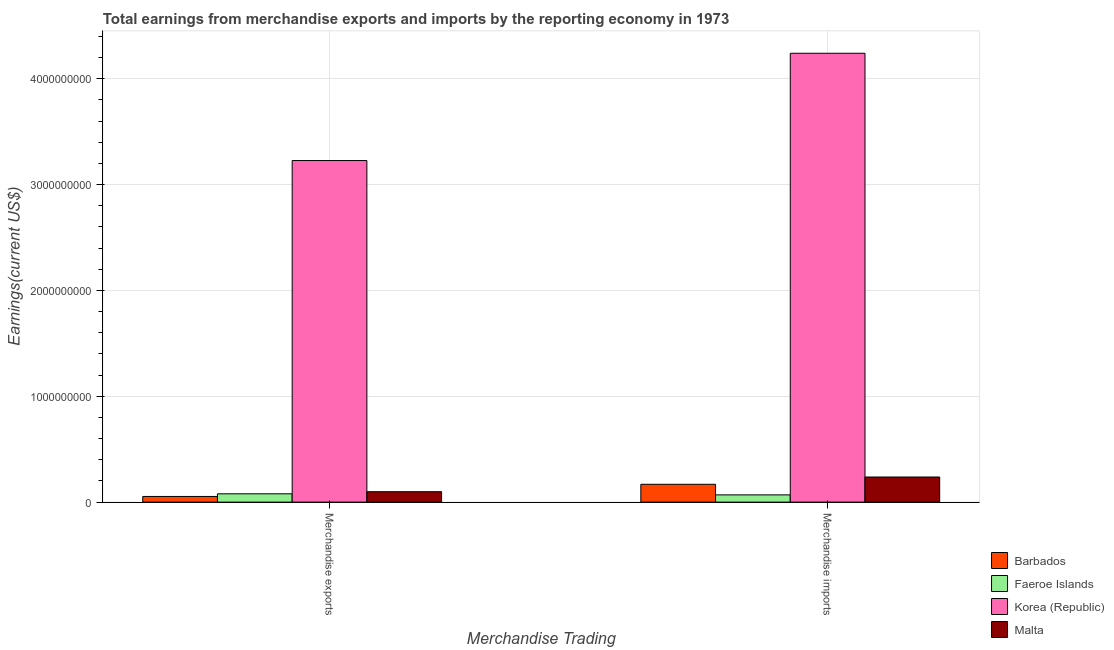How many different coloured bars are there?
Provide a succinct answer. 4. Are the number of bars per tick equal to the number of legend labels?
Ensure brevity in your answer.  Yes. Are the number of bars on each tick of the X-axis equal?
Your answer should be very brief. Yes. How many bars are there on the 1st tick from the left?
Your response must be concise. 4. What is the earnings from merchandise exports in Barbados?
Ensure brevity in your answer.  5.35e+07. Across all countries, what is the maximum earnings from merchandise imports?
Provide a succinct answer. 4.24e+09. Across all countries, what is the minimum earnings from merchandise exports?
Your answer should be compact. 5.35e+07. In which country was the earnings from merchandise exports maximum?
Provide a short and direct response. Korea (Republic). In which country was the earnings from merchandise imports minimum?
Give a very brief answer. Faeroe Islands. What is the total earnings from merchandise imports in the graph?
Give a very brief answer. 4.72e+09. What is the difference between the earnings from merchandise exports in Faeroe Islands and that in Korea (Republic)?
Give a very brief answer. -3.15e+09. What is the difference between the earnings from merchandise imports in Korea (Republic) and the earnings from merchandise exports in Malta?
Provide a succinct answer. 4.14e+09. What is the average earnings from merchandise imports per country?
Your answer should be compact. 1.18e+09. What is the difference between the earnings from merchandise imports and earnings from merchandise exports in Faeroe Islands?
Keep it short and to the point. -1.01e+07. In how many countries, is the earnings from merchandise imports greater than 600000000 US$?
Provide a short and direct response. 1. What is the ratio of the earnings from merchandise exports in Barbados to that in Malta?
Ensure brevity in your answer.  0.54. What does the 1st bar from the left in Merchandise imports represents?
Offer a very short reply. Barbados. What does the 3rd bar from the right in Merchandise imports represents?
Your answer should be compact. Faeroe Islands. How many bars are there?
Give a very brief answer. 8. Are all the bars in the graph horizontal?
Offer a very short reply. No. How many countries are there in the graph?
Your answer should be very brief. 4. What is the difference between two consecutive major ticks on the Y-axis?
Make the answer very short. 1.00e+09. Does the graph contain any zero values?
Give a very brief answer. No. How many legend labels are there?
Give a very brief answer. 4. How are the legend labels stacked?
Keep it short and to the point. Vertical. What is the title of the graph?
Your answer should be very brief. Total earnings from merchandise exports and imports by the reporting economy in 1973. What is the label or title of the X-axis?
Your response must be concise. Merchandise Trading. What is the label or title of the Y-axis?
Ensure brevity in your answer.  Earnings(current US$). What is the Earnings(current US$) of Barbados in Merchandise exports?
Your answer should be very brief. 5.35e+07. What is the Earnings(current US$) of Faeroe Islands in Merchandise exports?
Give a very brief answer. 7.85e+07. What is the Earnings(current US$) of Korea (Republic) in Merchandise exports?
Give a very brief answer. 3.23e+09. What is the Earnings(current US$) in Malta in Merchandise exports?
Provide a succinct answer. 9.85e+07. What is the Earnings(current US$) of Barbados in Merchandise imports?
Your answer should be very brief. 1.69e+08. What is the Earnings(current US$) of Faeroe Islands in Merchandise imports?
Your answer should be compact. 6.85e+07. What is the Earnings(current US$) of Korea (Republic) in Merchandise imports?
Provide a short and direct response. 4.24e+09. What is the Earnings(current US$) of Malta in Merchandise imports?
Offer a very short reply. 2.37e+08. Across all Merchandise Trading, what is the maximum Earnings(current US$) of Barbados?
Offer a terse response. 1.69e+08. Across all Merchandise Trading, what is the maximum Earnings(current US$) of Faeroe Islands?
Make the answer very short. 7.85e+07. Across all Merchandise Trading, what is the maximum Earnings(current US$) of Korea (Republic)?
Ensure brevity in your answer.  4.24e+09. Across all Merchandise Trading, what is the maximum Earnings(current US$) of Malta?
Your answer should be compact. 2.37e+08. Across all Merchandise Trading, what is the minimum Earnings(current US$) of Barbados?
Give a very brief answer. 5.35e+07. Across all Merchandise Trading, what is the minimum Earnings(current US$) in Faeroe Islands?
Offer a very short reply. 6.85e+07. Across all Merchandise Trading, what is the minimum Earnings(current US$) of Korea (Republic)?
Ensure brevity in your answer.  3.23e+09. Across all Merchandise Trading, what is the minimum Earnings(current US$) of Malta?
Make the answer very short. 9.85e+07. What is the total Earnings(current US$) in Barbados in the graph?
Make the answer very short. 2.22e+08. What is the total Earnings(current US$) of Faeroe Islands in the graph?
Your answer should be compact. 1.47e+08. What is the total Earnings(current US$) of Korea (Republic) in the graph?
Your answer should be very brief. 7.47e+09. What is the total Earnings(current US$) in Malta in the graph?
Give a very brief answer. 3.36e+08. What is the difference between the Earnings(current US$) in Barbados in Merchandise exports and that in Merchandise imports?
Keep it short and to the point. -1.15e+08. What is the difference between the Earnings(current US$) in Faeroe Islands in Merchandise exports and that in Merchandise imports?
Your answer should be compact. 1.01e+07. What is the difference between the Earnings(current US$) in Korea (Republic) in Merchandise exports and that in Merchandise imports?
Ensure brevity in your answer.  -1.01e+09. What is the difference between the Earnings(current US$) of Malta in Merchandise exports and that in Merchandise imports?
Your answer should be very brief. -1.39e+08. What is the difference between the Earnings(current US$) in Barbados in Merchandise exports and the Earnings(current US$) in Faeroe Islands in Merchandise imports?
Provide a succinct answer. -1.49e+07. What is the difference between the Earnings(current US$) of Barbados in Merchandise exports and the Earnings(current US$) of Korea (Republic) in Merchandise imports?
Offer a terse response. -4.19e+09. What is the difference between the Earnings(current US$) in Barbados in Merchandise exports and the Earnings(current US$) in Malta in Merchandise imports?
Keep it short and to the point. -1.84e+08. What is the difference between the Earnings(current US$) of Faeroe Islands in Merchandise exports and the Earnings(current US$) of Korea (Republic) in Merchandise imports?
Your response must be concise. -4.16e+09. What is the difference between the Earnings(current US$) of Faeroe Islands in Merchandise exports and the Earnings(current US$) of Malta in Merchandise imports?
Make the answer very short. -1.59e+08. What is the difference between the Earnings(current US$) of Korea (Republic) in Merchandise exports and the Earnings(current US$) of Malta in Merchandise imports?
Provide a short and direct response. 2.99e+09. What is the average Earnings(current US$) in Barbados per Merchandise Trading?
Your answer should be compact. 1.11e+08. What is the average Earnings(current US$) of Faeroe Islands per Merchandise Trading?
Your answer should be very brief. 7.35e+07. What is the average Earnings(current US$) of Korea (Republic) per Merchandise Trading?
Make the answer very short. 3.73e+09. What is the average Earnings(current US$) in Malta per Merchandise Trading?
Keep it short and to the point. 1.68e+08. What is the difference between the Earnings(current US$) in Barbados and Earnings(current US$) in Faeroe Islands in Merchandise exports?
Make the answer very short. -2.50e+07. What is the difference between the Earnings(current US$) in Barbados and Earnings(current US$) in Korea (Republic) in Merchandise exports?
Your answer should be very brief. -3.17e+09. What is the difference between the Earnings(current US$) of Barbados and Earnings(current US$) of Malta in Merchandise exports?
Offer a very short reply. -4.49e+07. What is the difference between the Earnings(current US$) of Faeroe Islands and Earnings(current US$) of Korea (Republic) in Merchandise exports?
Keep it short and to the point. -3.15e+09. What is the difference between the Earnings(current US$) in Faeroe Islands and Earnings(current US$) in Malta in Merchandise exports?
Your answer should be very brief. -1.99e+07. What is the difference between the Earnings(current US$) of Korea (Republic) and Earnings(current US$) of Malta in Merchandise exports?
Your answer should be compact. 3.13e+09. What is the difference between the Earnings(current US$) of Barbados and Earnings(current US$) of Faeroe Islands in Merchandise imports?
Provide a short and direct response. 1.00e+08. What is the difference between the Earnings(current US$) in Barbados and Earnings(current US$) in Korea (Republic) in Merchandise imports?
Offer a very short reply. -4.07e+09. What is the difference between the Earnings(current US$) of Barbados and Earnings(current US$) of Malta in Merchandise imports?
Your response must be concise. -6.88e+07. What is the difference between the Earnings(current US$) in Faeroe Islands and Earnings(current US$) in Korea (Republic) in Merchandise imports?
Your response must be concise. -4.17e+09. What is the difference between the Earnings(current US$) in Faeroe Islands and Earnings(current US$) in Malta in Merchandise imports?
Your answer should be very brief. -1.69e+08. What is the difference between the Earnings(current US$) of Korea (Republic) and Earnings(current US$) of Malta in Merchandise imports?
Your response must be concise. 4.00e+09. What is the ratio of the Earnings(current US$) of Barbados in Merchandise exports to that in Merchandise imports?
Your response must be concise. 0.32. What is the ratio of the Earnings(current US$) in Faeroe Islands in Merchandise exports to that in Merchandise imports?
Give a very brief answer. 1.15. What is the ratio of the Earnings(current US$) of Korea (Republic) in Merchandise exports to that in Merchandise imports?
Give a very brief answer. 0.76. What is the ratio of the Earnings(current US$) of Malta in Merchandise exports to that in Merchandise imports?
Keep it short and to the point. 0.41. What is the difference between the highest and the second highest Earnings(current US$) in Barbados?
Your answer should be very brief. 1.15e+08. What is the difference between the highest and the second highest Earnings(current US$) in Faeroe Islands?
Give a very brief answer. 1.01e+07. What is the difference between the highest and the second highest Earnings(current US$) in Korea (Republic)?
Provide a succinct answer. 1.01e+09. What is the difference between the highest and the second highest Earnings(current US$) of Malta?
Your response must be concise. 1.39e+08. What is the difference between the highest and the lowest Earnings(current US$) of Barbados?
Provide a short and direct response. 1.15e+08. What is the difference between the highest and the lowest Earnings(current US$) of Faeroe Islands?
Your answer should be compact. 1.01e+07. What is the difference between the highest and the lowest Earnings(current US$) of Korea (Republic)?
Give a very brief answer. 1.01e+09. What is the difference between the highest and the lowest Earnings(current US$) in Malta?
Make the answer very short. 1.39e+08. 